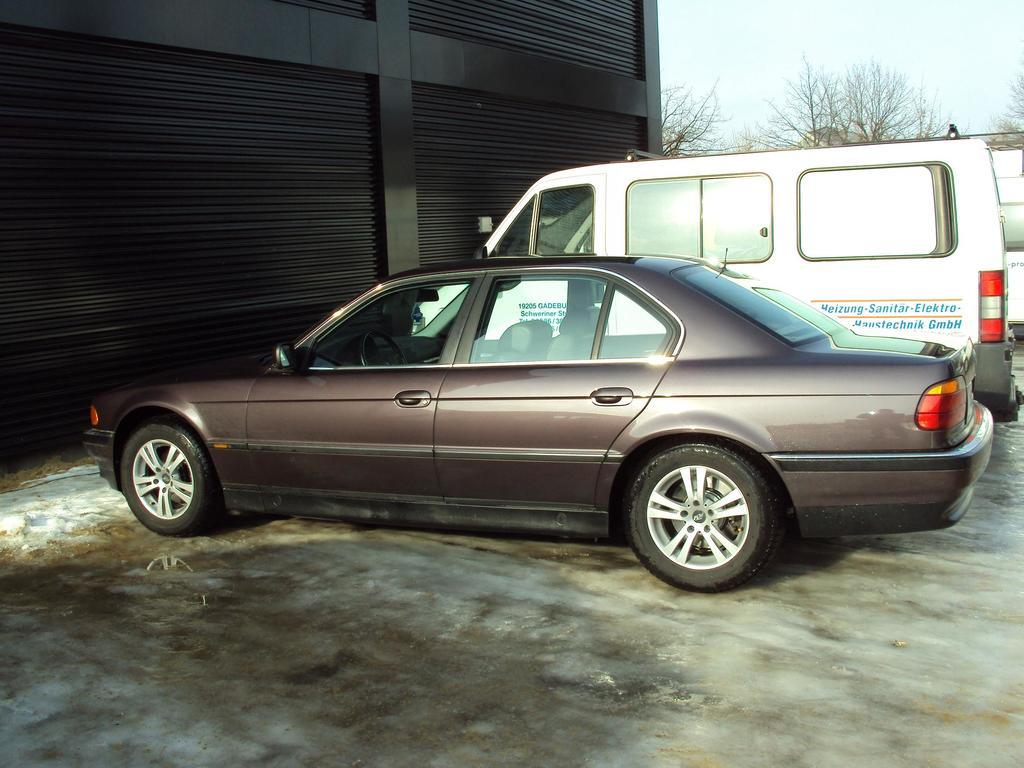What types of objects are present in the image? There are vehicles in the image. Can you describe the building on the left side of the image? The building on the left side of the image is black in color. What can be seen in the background of the image? There are trees and the sky visible in the background of the image. How many spots can be seen on the vehicles in the image? There is no mention of spots on the vehicles in the image, so it cannot be determined from the provided facts. 